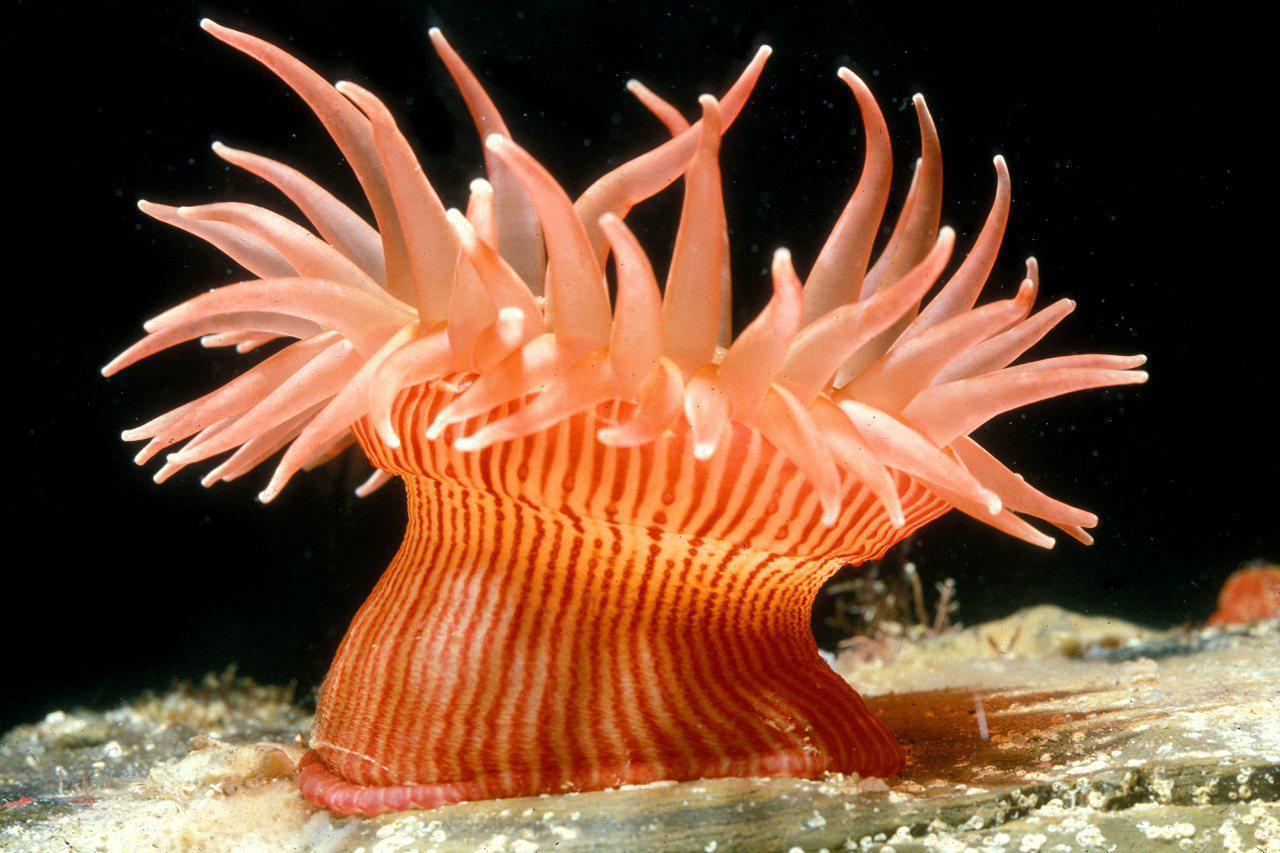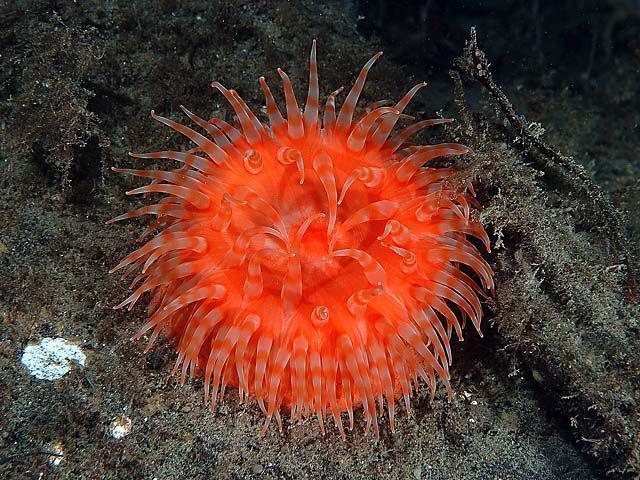The first image is the image on the left, the second image is the image on the right. For the images shown, is this caption "In at least one image from an aerial  view you can see a circle orange corral with at  least 20 arms." true? Answer yes or no. Yes. The first image is the image on the left, the second image is the image on the right. For the images displayed, is the sentence "The left image shows a side view of an anemone with an orange stalk and orange tendrils, and the right image shows a rounded orange anemone with no stalk." factually correct? Answer yes or no. Yes. 